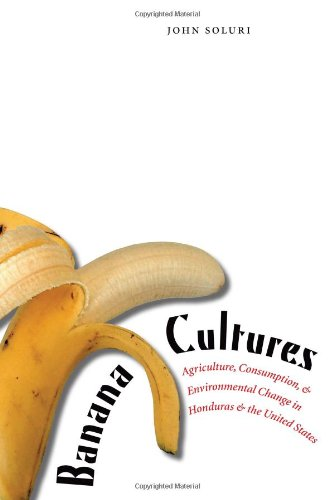Is this a journey related book? No, this book does not center on journeys or travel narratives; instead, it offers a profound examination of historical and environmental issues within the agricultural industry. 